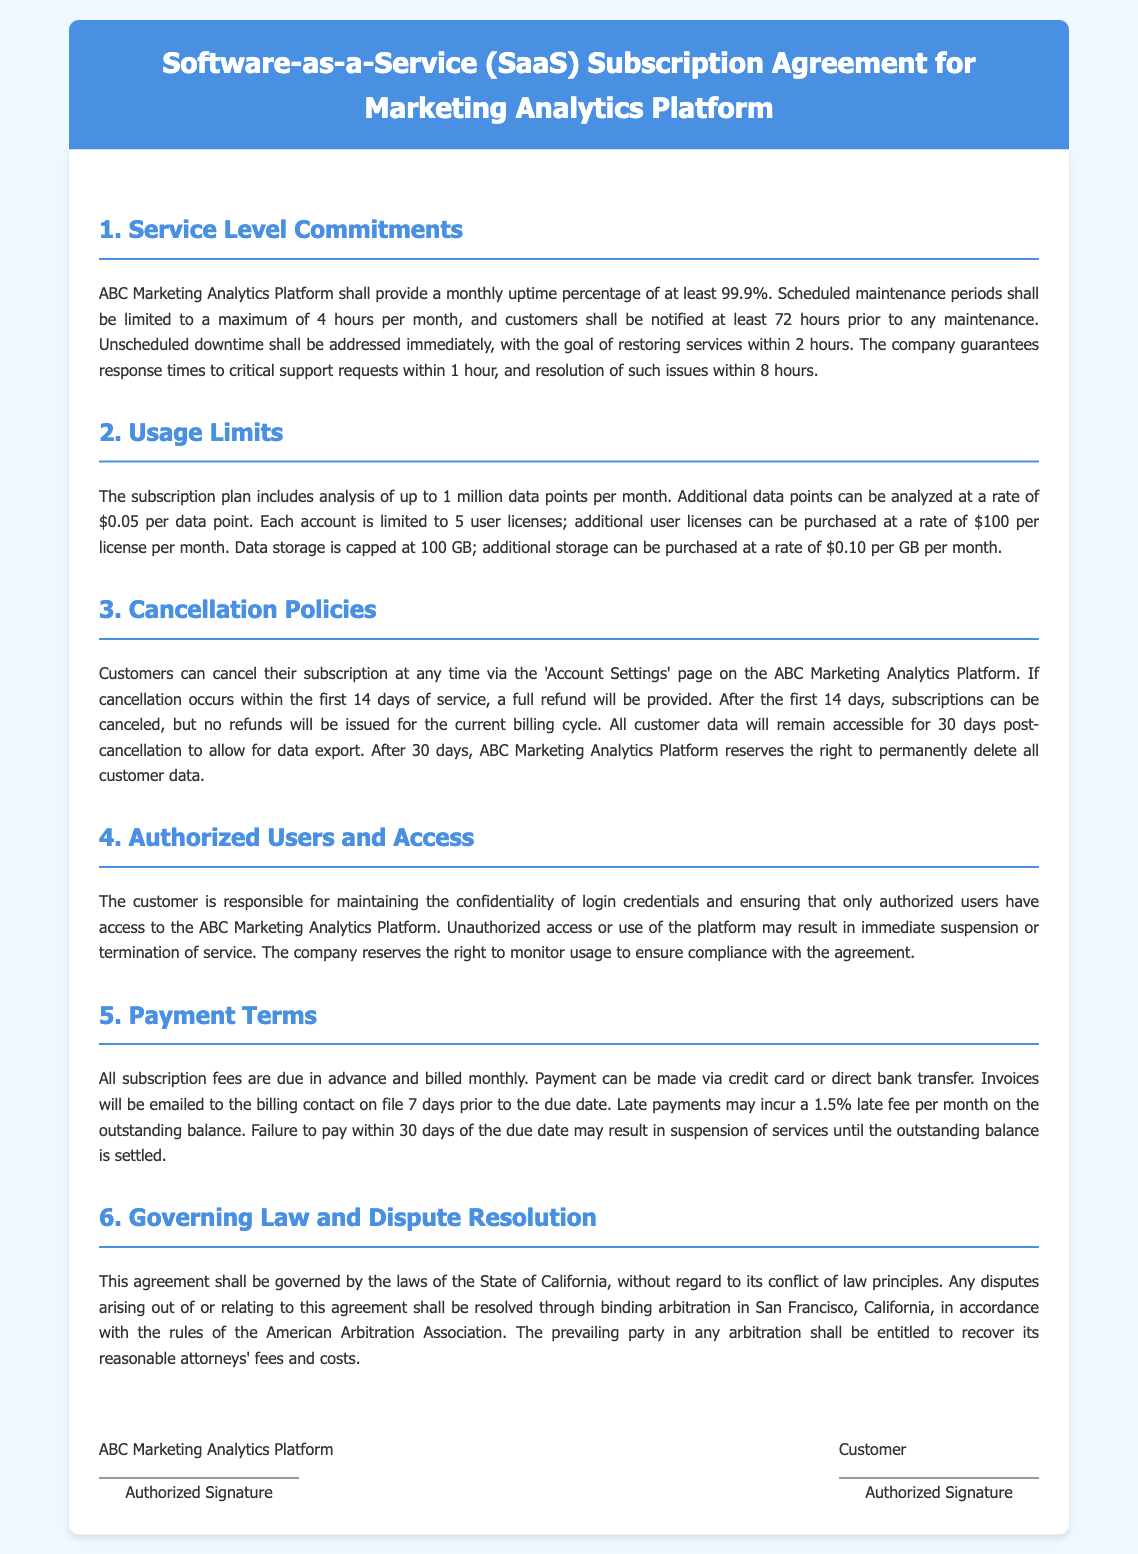What is the monthly uptime percentage guaranteed? The document states that the monthly uptime percentage shall be at least 99.9%.
Answer: 99.9% How many data points can be analyzed per month under the subscription plan? The document specifies that the subscription plan includes analysis of up to 1 million data points per month.
Answer: 1 million What is the penalty for late payments per month? The contract mentions that late payments may incur a 1.5% late fee per month on the outstanding balance.
Answer: 1.5% What is the storage cap for data under the subscription plan? According to the document, the data storage is capped at 100 GB.
Answer: 100 GB How much will it cost for an additional user license per month? The document states that additional user licenses can be purchased at a rate of $100 per license per month.
Answer: $100 What is the notification period for scheduled maintenance? The document indicates that customers shall be notified at least 72 hours prior to any maintenance.
Answer: 72 hours What happens to customer data after cancellation? The contract states that all customer data will remain accessible for 30 days post-cancellation.
Answer: 30 days What is the governing law for this agreement? The document specifies that the agreement shall be governed by the laws of the State of California.
Answer: California What is the time frame for refund eligibility after cancellation? The document mentions that if cancellation occurs within the first 14 days of service, a full refund will be provided.
Answer: 14 days 